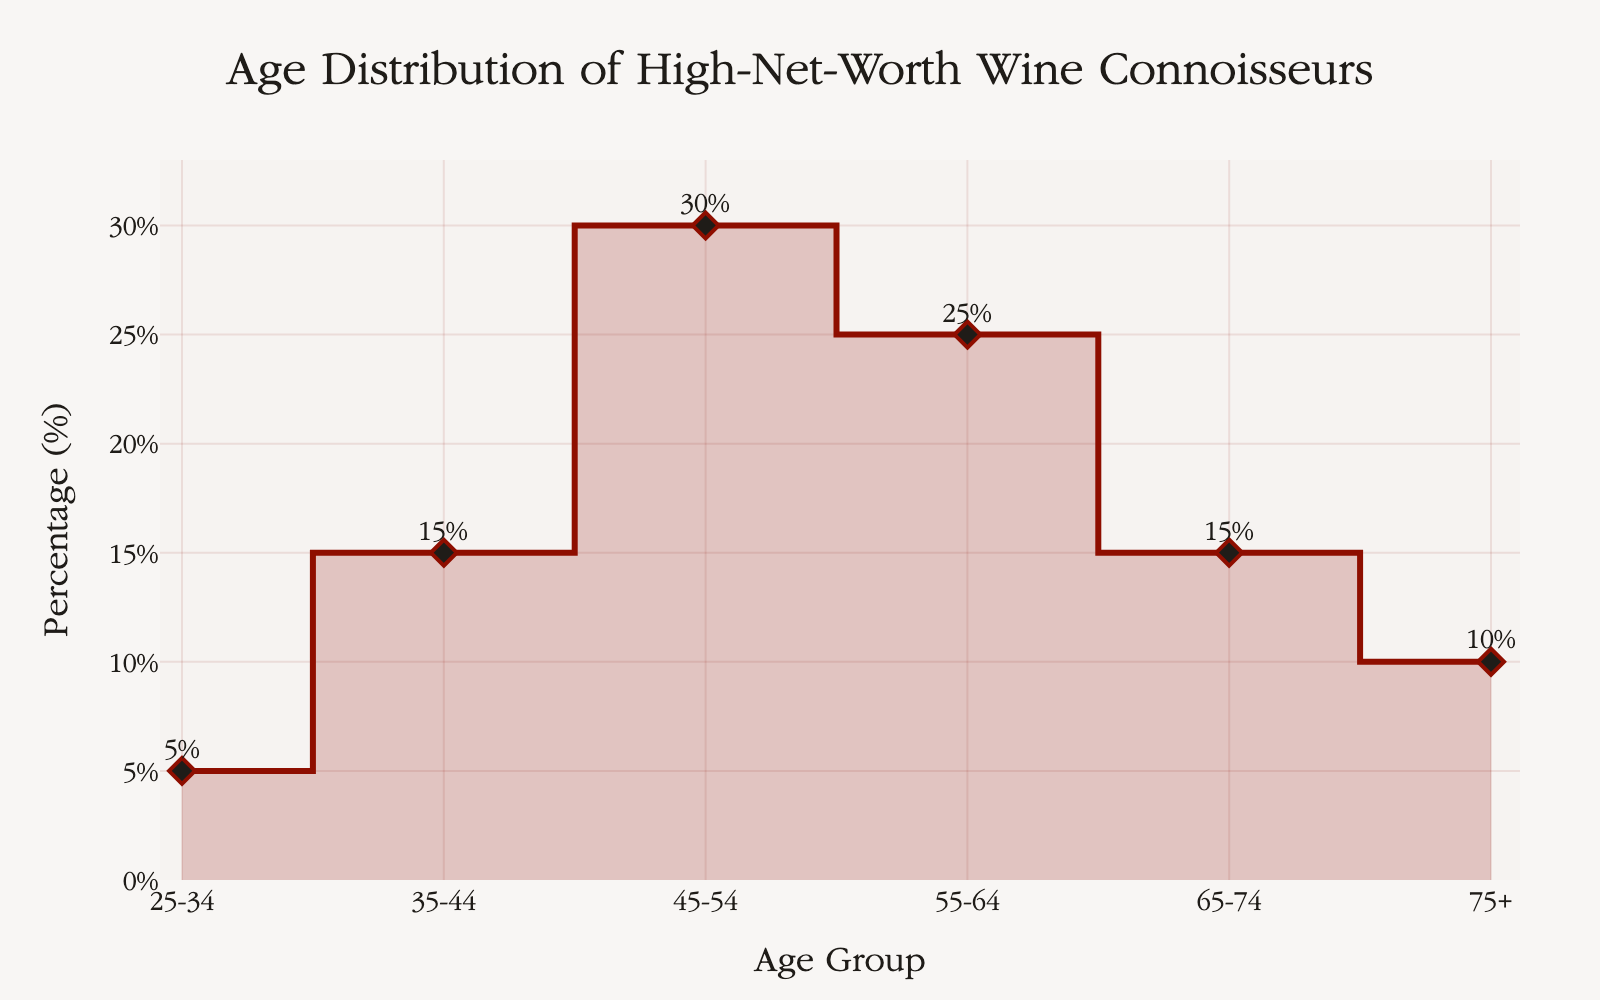What is the title of the figure? The title of the figure is clearly visible at the top. Reading it directly will provide the answer.
Answer: Age Distribution of High-Net-Worth Wine Connoisseurs Which age group has the highest percentage? Look at the y-values of the plotted points; the highest percentage corresponds to the age group 45-54.
Answer: 45-54 What is the percentage for the 35-44 age group? Locate the data point for the 35-44 age group on the x-axis and read its corresponding y-value.
Answer: 15% Which age groups have the same percentage? Compare the percentages of each age group. Notice that both the 35-44 and 65-74 age groups share the same percentage.
Answer: 35-44 and 65-74 What's the total percentage of individuals above 65 years old? Sum the percentages of the age groups 65-74 and 75+. This is 15% + 10%.
Answer: 25% Which age group has the smallest percentage of high-net-worth individuals purchasing luxury wine? Look for the data point with the lowest y-value. This corresponds to the age group 25-34.
Answer: 25-34 How many age groups are represented in the figure? Count the distinct age groups listed on the x-axis.
Answer: 6 What's the difference in percentage between 45-54 and 55-64 age groups? Subtract the percentage of the 55-64 age group from the 45-54 age group, which is 30% - 25%.
Answer: 5% Are there more individuals in the 55-64 age group or the 75+ age group? Compare the percentages between these two age groups; 25% for 55-64 and 10% for 75+.
Answer: 55-64 Which age group has a percentage of 10%? Look for the data point where the y-value is 10%; this corresponds to the 75+ age group.
Answer: 75+ 